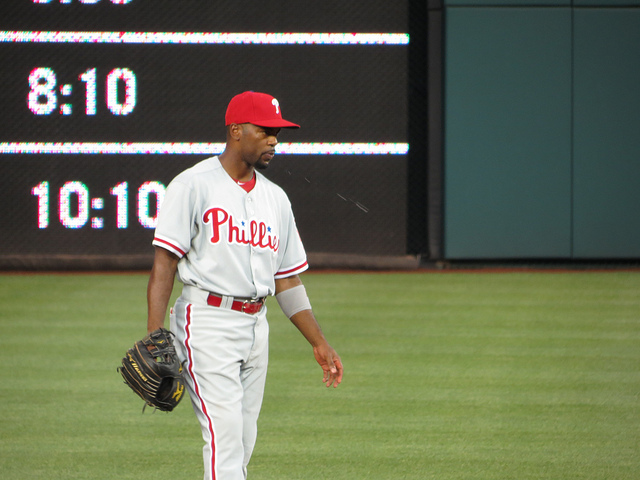Please extract the text content from this image. 10 10 8 10 Phillie 